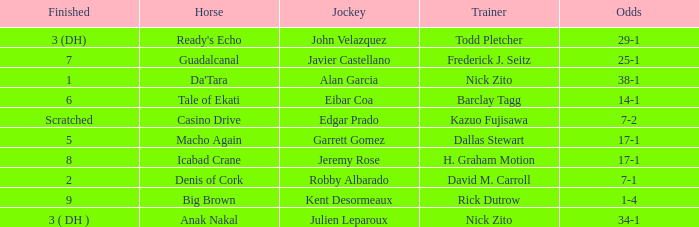Who is the Jockey for guadalcanal? Javier Castellano. Can you give me this table as a dict? {'header': ['Finished', 'Horse', 'Jockey', 'Trainer', 'Odds'], 'rows': [['3 (DH)', "Ready's Echo", 'John Velazquez', 'Todd Pletcher', '29-1'], ['7', 'Guadalcanal', 'Javier Castellano', 'Frederick J. Seitz', '25-1'], ['1', "Da'Tara", 'Alan Garcia', 'Nick Zito', '38-1'], ['6', 'Tale of Ekati', 'Eibar Coa', 'Barclay Tagg', '14-1'], ['Scratched', 'Casino Drive', 'Edgar Prado', 'Kazuo Fujisawa', '7-2'], ['5', 'Macho Again', 'Garrett Gomez', 'Dallas Stewart', '17-1'], ['8', 'Icabad Crane', 'Jeremy Rose', 'H. Graham Motion', '17-1'], ['2', 'Denis of Cork', 'Robby Albarado', 'David M. Carroll', '7-1'], ['9', 'Big Brown', 'Kent Desormeaux', 'Rick Dutrow', '1-4'], ['3 ( DH )', 'Anak Nakal', 'Julien Leparoux', 'Nick Zito', '34-1']]} 